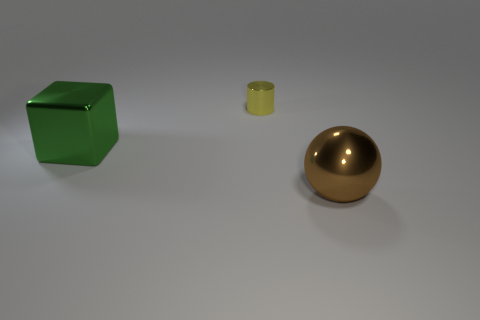Are there any big green metal objects that are on the right side of the large metal thing behind the brown object that is in front of the big green object?
Provide a succinct answer. No. Are the large object that is in front of the large metal block and the large object behind the brown metallic thing made of the same material?
Your answer should be very brief. Yes. What number of objects are either yellow metallic objects or big metallic objects to the right of the tiny metal object?
Keep it short and to the point. 2. How many brown objects have the same shape as the tiny yellow metal thing?
Your response must be concise. 0. What material is the object that is the same size as the green block?
Provide a succinct answer. Metal. How big is the thing that is in front of the large thing behind the large metallic thing right of the big green shiny block?
Provide a short and direct response. Large. Do the metallic object that is in front of the large cube and the large object that is on the left side of the big brown metallic object have the same color?
Offer a very short reply. No. What number of yellow things are tiny metal cubes or big metallic spheres?
Provide a succinct answer. 0. What number of brown shiny things have the same size as the metal cylinder?
Keep it short and to the point. 0. Are the large thing to the left of the large ball and the cylinder made of the same material?
Provide a succinct answer. Yes. 